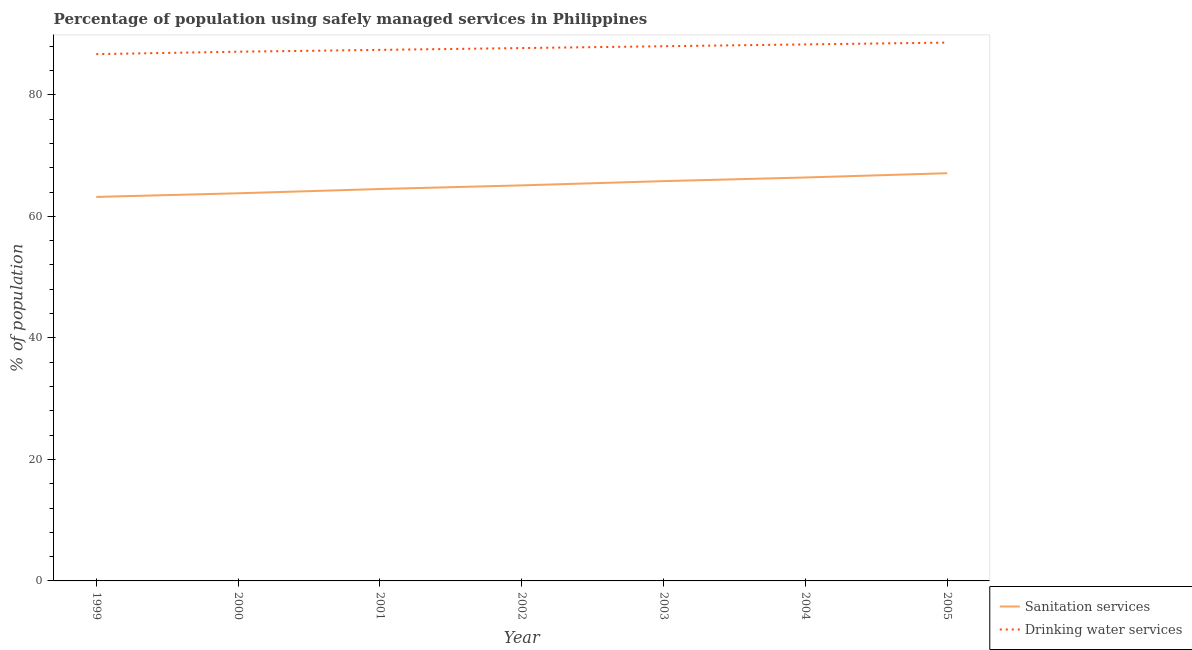How many different coloured lines are there?
Provide a short and direct response. 2. What is the percentage of population who used drinking water services in 2004?
Ensure brevity in your answer.  88.3. Across all years, what is the maximum percentage of population who used drinking water services?
Give a very brief answer. 88.6. Across all years, what is the minimum percentage of population who used sanitation services?
Offer a terse response. 63.2. What is the total percentage of population who used sanitation services in the graph?
Provide a succinct answer. 455.9. What is the difference between the percentage of population who used drinking water services in 2003 and the percentage of population who used sanitation services in 2002?
Give a very brief answer. 22.9. What is the average percentage of population who used sanitation services per year?
Give a very brief answer. 65.13. In the year 1999, what is the difference between the percentage of population who used drinking water services and percentage of population who used sanitation services?
Make the answer very short. 23.5. In how many years, is the percentage of population who used drinking water services greater than 24 %?
Keep it short and to the point. 7. What is the ratio of the percentage of population who used sanitation services in 2003 to that in 2004?
Provide a short and direct response. 0.99. Is the difference between the percentage of population who used drinking water services in 2001 and 2004 greater than the difference between the percentage of population who used sanitation services in 2001 and 2004?
Ensure brevity in your answer.  Yes. What is the difference between the highest and the second highest percentage of population who used drinking water services?
Offer a very short reply. 0.3. What is the difference between the highest and the lowest percentage of population who used sanitation services?
Ensure brevity in your answer.  3.9. In how many years, is the percentage of population who used sanitation services greater than the average percentage of population who used sanitation services taken over all years?
Keep it short and to the point. 3. Is the sum of the percentage of population who used drinking water services in 2000 and 2004 greater than the maximum percentage of population who used sanitation services across all years?
Offer a very short reply. Yes. Is the percentage of population who used drinking water services strictly greater than the percentage of population who used sanitation services over the years?
Make the answer very short. Yes. Is the percentage of population who used sanitation services strictly less than the percentage of population who used drinking water services over the years?
Give a very brief answer. Yes. How many lines are there?
Your response must be concise. 2. How many years are there in the graph?
Give a very brief answer. 7. Are the values on the major ticks of Y-axis written in scientific E-notation?
Provide a succinct answer. No. Does the graph contain any zero values?
Your response must be concise. No. How are the legend labels stacked?
Your answer should be compact. Vertical. What is the title of the graph?
Make the answer very short. Percentage of population using safely managed services in Philippines. Does "Private funds" appear as one of the legend labels in the graph?
Your answer should be very brief. No. What is the label or title of the X-axis?
Keep it short and to the point. Year. What is the label or title of the Y-axis?
Provide a succinct answer. % of population. What is the % of population of Sanitation services in 1999?
Give a very brief answer. 63.2. What is the % of population in Drinking water services in 1999?
Provide a short and direct response. 86.7. What is the % of population in Sanitation services in 2000?
Provide a short and direct response. 63.8. What is the % of population of Drinking water services in 2000?
Make the answer very short. 87.1. What is the % of population of Sanitation services in 2001?
Offer a very short reply. 64.5. What is the % of population in Drinking water services in 2001?
Give a very brief answer. 87.4. What is the % of population in Sanitation services in 2002?
Ensure brevity in your answer.  65.1. What is the % of population of Drinking water services in 2002?
Your answer should be very brief. 87.7. What is the % of population in Sanitation services in 2003?
Your answer should be very brief. 65.8. What is the % of population of Sanitation services in 2004?
Your response must be concise. 66.4. What is the % of population in Drinking water services in 2004?
Your answer should be very brief. 88.3. What is the % of population of Sanitation services in 2005?
Provide a short and direct response. 67.1. What is the % of population in Drinking water services in 2005?
Provide a short and direct response. 88.6. Across all years, what is the maximum % of population in Sanitation services?
Your answer should be compact. 67.1. Across all years, what is the maximum % of population in Drinking water services?
Your response must be concise. 88.6. Across all years, what is the minimum % of population in Sanitation services?
Your answer should be very brief. 63.2. Across all years, what is the minimum % of population of Drinking water services?
Your response must be concise. 86.7. What is the total % of population of Sanitation services in the graph?
Your answer should be compact. 455.9. What is the total % of population in Drinking water services in the graph?
Provide a short and direct response. 613.8. What is the difference between the % of population in Drinking water services in 1999 and that in 2001?
Your answer should be compact. -0.7. What is the difference between the % of population in Drinking water services in 1999 and that in 2002?
Ensure brevity in your answer.  -1. What is the difference between the % of population of Sanitation services in 1999 and that in 2003?
Your answer should be very brief. -2.6. What is the difference between the % of population of Sanitation services in 1999 and that in 2004?
Make the answer very short. -3.2. What is the difference between the % of population in Sanitation services in 1999 and that in 2005?
Provide a succinct answer. -3.9. What is the difference between the % of population of Drinking water services in 1999 and that in 2005?
Ensure brevity in your answer.  -1.9. What is the difference between the % of population in Drinking water services in 2000 and that in 2001?
Make the answer very short. -0.3. What is the difference between the % of population of Sanitation services in 2000 and that in 2003?
Keep it short and to the point. -2. What is the difference between the % of population in Drinking water services in 2000 and that in 2003?
Provide a succinct answer. -0.9. What is the difference between the % of population in Sanitation services in 2000 and that in 2005?
Give a very brief answer. -3.3. What is the difference between the % of population of Sanitation services in 2001 and that in 2002?
Provide a short and direct response. -0.6. What is the difference between the % of population of Sanitation services in 2001 and that in 2003?
Your response must be concise. -1.3. What is the difference between the % of population of Sanitation services in 2001 and that in 2004?
Your response must be concise. -1.9. What is the difference between the % of population of Drinking water services in 2001 and that in 2005?
Give a very brief answer. -1.2. What is the difference between the % of population in Sanitation services in 2002 and that in 2003?
Ensure brevity in your answer.  -0.7. What is the difference between the % of population of Drinking water services in 2002 and that in 2003?
Offer a very short reply. -0.3. What is the difference between the % of population of Sanitation services in 2002 and that in 2004?
Your answer should be compact. -1.3. What is the difference between the % of population of Drinking water services in 2002 and that in 2005?
Your answer should be compact. -0.9. What is the difference between the % of population of Sanitation services in 2003 and that in 2004?
Offer a terse response. -0.6. What is the difference between the % of population in Drinking water services in 2003 and that in 2004?
Provide a succinct answer. -0.3. What is the difference between the % of population in Sanitation services in 2003 and that in 2005?
Provide a short and direct response. -1.3. What is the difference between the % of population of Drinking water services in 2003 and that in 2005?
Your response must be concise. -0.6. What is the difference between the % of population of Sanitation services in 1999 and the % of population of Drinking water services in 2000?
Provide a short and direct response. -23.9. What is the difference between the % of population of Sanitation services in 1999 and the % of population of Drinking water services in 2001?
Your answer should be very brief. -24.2. What is the difference between the % of population in Sanitation services in 1999 and the % of population in Drinking water services in 2002?
Offer a terse response. -24.5. What is the difference between the % of population of Sanitation services in 1999 and the % of population of Drinking water services in 2003?
Provide a succinct answer. -24.8. What is the difference between the % of population in Sanitation services in 1999 and the % of population in Drinking water services in 2004?
Make the answer very short. -25.1. What is the difference between the % of population of Sanitation services in 1999 and the % of population of Drinking water services in 2005?
Offer a very short reply. -25.4. What is the difference between the % of population of Sanitation services in 2000 and the % of population of Drinking water services in 2001?
Keep it short and to the point. -23.6. What is the difference between the % of population in Sanitation services in 2000 and the % of population in Drinking water services in 2002?
Your response must be concise. -23.9. What is the difference between the % of population of Sanitation services in 2000 and the % of population of Drinking water services in 2003?
Offer a very short reply. -24.2. What is the difference between the % of population in Sanitation services in 2000 and the % of population in Drinking water services in 2004?
Offer a very short reply. -24.5. What is the difference between the % of population in Sanitation services in 2000 and the % of population in Drinking water services in 2005?
Your answer should be very brief. -24.8. What is the difference between the % of population of Sanitation services in 2001 and the % of population of Drinking water services in 2002?
Offer a very short reply. -23.2. What is the difference between the % of population in Sanitation services in 2001 and the % of population in Drinking water services in 2003?
Give a very brief answer. -23.5. What is the difference between the % of population in Sanitation services in 2001 and the % of population in Drinking water services in 2004?
Your answer should be very brief. -23.8. What is the difference between the % of population in Sanitation services in 2001 and the % of population in Drinking water services in 2005?
Make the answer very short. -24.1. What is the difference between the % of population in Sanitation services in 2002 and the % of population in Drinking water services in 2003?
Keep it short and to the point. -22.9. What is the difference between the % of population of Sanitation services in 2002 and the % of population of Drinking water services in 2004?
Make the answer very short. -23.2. What is the difference between the % of population of Sanitation services in 2002 and the % of population of Drinking water services in 2005?
Offer a terse response. -23.5. What is the difference between the % of population of Sanitation services in 2003 and the % of population of Drinking water services in 2004?
Provide a short and direct response. -22.5. What is the difference between the % of population in Sanitation services in 2003 and the % of population in Drinking water services in 2005?
Keep it short and to the point. -22.8. What is the difference between the % of population of Sanitation services in 2004 and the % of population of Drinking water services in 2005?
Ensure brevity in your answer.  -22.2. What is the average % of population in Sanitation services per year?
Provide a succinct answer. 65.13. What is the average % of population of Drinking water services per year?
Offer a very short reply. 87.69. In the year 1999, what is the difference between the % of population of Sanitation services and % of population of Drinking water services?
Give a very brief answer. -23.5. In the year 2000, what is the difference between the % of population of Sanitation services and % of population of Drinking water services?
Offer a terse response. -23.3. In the year 2001, what is the difference between the % of population in Sanitation services and % of population in Drinking water services?
Your response must be concise. -22.9. In the year 2002, what is the difference between the % of population of Sanitation services and % of population of Drinking water services?
Offer a very short reply. -22.6. In the year 2003, what is the difference between the % of population of Sanitation services and % of population of Drinking water services?
Ensure brevity in your answer.  -22.2. In the year 2004, what is the difference between the % of population of Sanitation services and % of population of Drinking water services?
Give a very brief answer. -21.9. In the year 2005, what is the difference between the % of population of Sanitation services and % of population of Drinking water services?
Your answer should be very brief. -21.5. What is the ratio of the % of population of Sanitation services in 1999 to that in 2000?
Make the answer very short. 0.99. What is the ratio of the % of population of Sanitation services in 1999 to that in 2001?
Ensure brevity in your answer.  0.98. What is the ratio of the % of population of Drinking water services in 1999 to that in 2001?
Give a very brief answer. 0.99. What is the ratio of the % of population in Sanitation services in 1999 to that in 2002?
Offer a terse response. 0.97. What is the ratio of the % of population in Sanitation services in 1999 to that in 2003?
Offer a terse response. 0.96. What is the ratio of the % of population of Drinking water services in 1999 to that in 2003?
Provide a succinct answer. 0.99. What is the ratio of the % of population in Sanitation services in 1999 to that in 2004?
Your answer should be compact. 0.95. What is the ratio of the % of population of Drinking water services in 1999 to that in 2004?
Your answer should be compact. 0.98. What is the ratio of the % of population of Sanitation services in 1999 to that in 2005?
Provide a short and direct response. 0.94. What is the ratio of the % of population of Drinking water services in 1999 to that in 2005?
Ensure brevity in your answer.  0.98. What is the ratio of the % of population of Sanitation services in 2000 to that in 2001?
Your answer should be compact. 0.99. What is the ratio of the % of population of Drinking water services in 2000 to that in 2001?
Your answer should be very brief. 1. What is the ratio of the % of population of Sanitation services in 2000 to that in 2002?
Give a very brief answer. 0.98. What is the ratio of the % of population in Drinking water services in 2000 to that in 2002?
Give a very brief answer. 0.99. What is the ratio of the % of population of Sanitation services in 2000 to that in 2003?
Your answer should be compact. 0.97. What is the ratio of the % of population in Sanitation services in 2000 to that in 2004?
Offer a very short reply. 0.96. What is the ratio of the % of population of Drinking water services in 2000 to that in 2004?
Ensure brevity in your answer.  0.99. What is the ratio of the % of population of Sanitation services in 2000 to that in 2005?
Make the answer very short. 0.95. What is the ratio of the % of population of Drinking water services in 2000 to that in 2005?
Offer a terse response. 0.98. What is the ratio of the % of population of Sanitation services in 2001 to that in 2003?
Your response must be concise. 0.98. What is the ratio of the % of population of Drinking water services in 2001 to that in 2003?
Offer a very short reply. 0.99. What is the ratio of the % of population of Sanitation services in 2001 to that in 2004?
Ensure brevity in your answer.  0.97. What is the ratio of the % of population in Sanitation services in 2001 to that in 2005?
Ensure brevity in your answer.  0.96. What is the ratio of the % of population in Drinking water services in 2001 to that in 2005?
Provide a succinct answer. 0.99. What is the ratio of the % of population in Drinking water services in 2002 to that in 2003?
Offer a terse response. 1. What is the ratio of the % of population of Sanitation services in 2002 to that in 2004?
Give a very brief answer. 0.98. What is the ratio of the % of population in Drinking water services in 2002 to that in 2004?
Make the answer very short. 0.99. What is the ratio of the % of population of Sanitation services in 2002 to that in 2005?
Your answer should be very brief. 0.97. What is the ratio of the % of population of Drinking water services in 2002 to that in 2005?
Provide a short and direct response. 0.99. What is the ratio of the % of population of Sanitation services in 2003 to that in 2004?
Ensure brevity in your answer.  0.99. What is the ratio of the % of population of Sanitation services in 2003 to that in 2005?
Make the answer very short. 0.98. What is the ratio of the % of population of Sanitation services in 2004 to that in 2005?
Offer a terse response. 0.99. What is the ratio of the % of population of Drinking water services in 2004 to that in 2005?
Give a very brief answer. 1. What is the difference between the highest and the lowest % of population in Sanitation services?
Offer a very short reply. 3.9. What is the difference between the highest and the lowest % of population in Drinking water services?
Your answer should be compact. 1.9. 